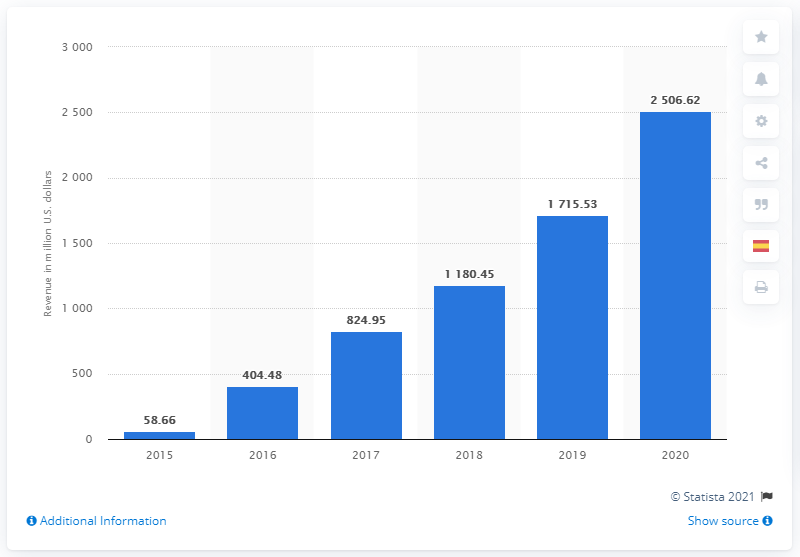Mention a couple of crucial points in this snapshot. In 2020, Snap generated approximately $1715.53 in revenue. In the previous year, Snap's revenue was 1715.53... 